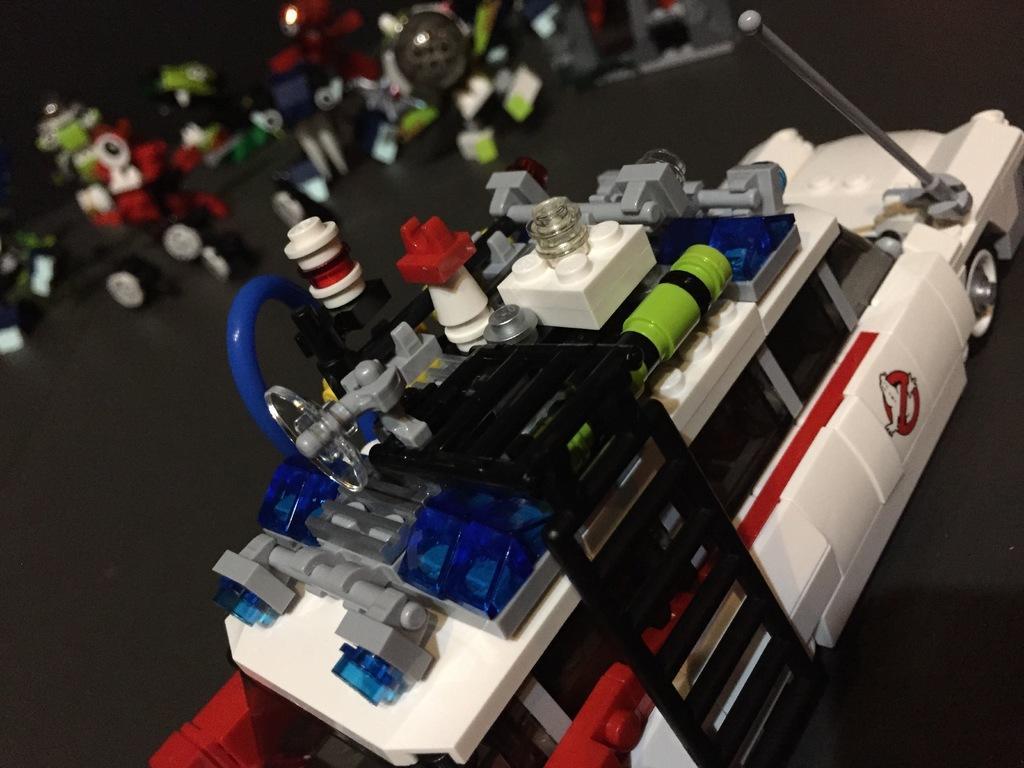Describe this image in one or two sentences. In this picture there is a model of toy car in multi color and there are other parts at the left side of the image. 